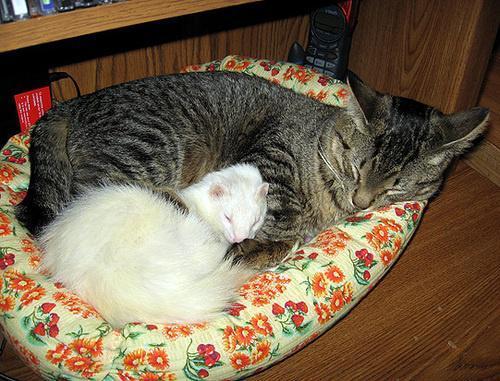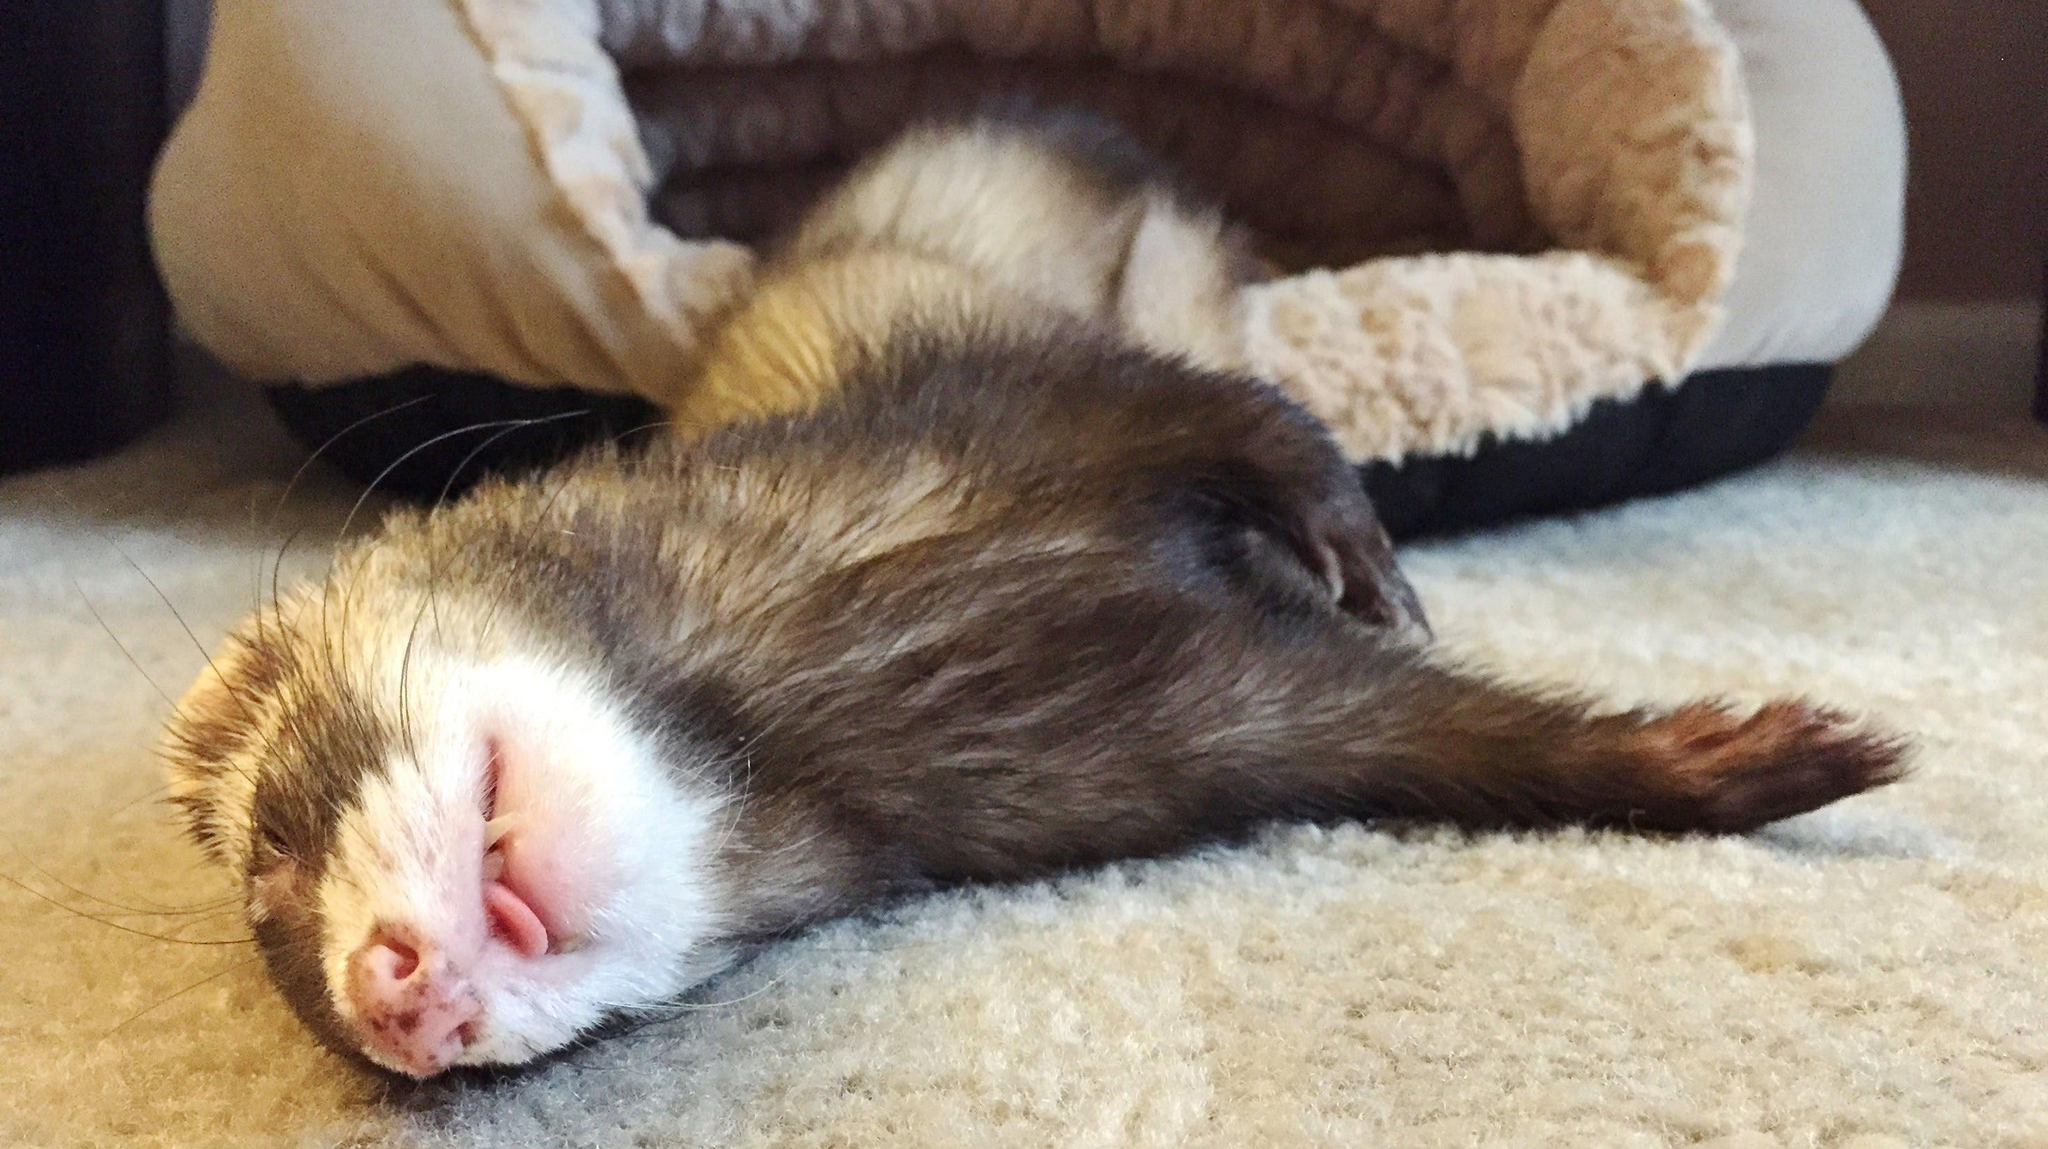The first image is the image on the left, the second image is the image on the right. Evaluate the accuracy of this statement regarding the images: "In one image there is a lone ferret sleeping with its tongue sticking out.". Is it true? Answer yes or no. Yes. The first image is the image on the left, the second image is the image on the right. Considering the images on both sides, is "There are exactly three ferrets in total." valid? Answer yes or no. No. 